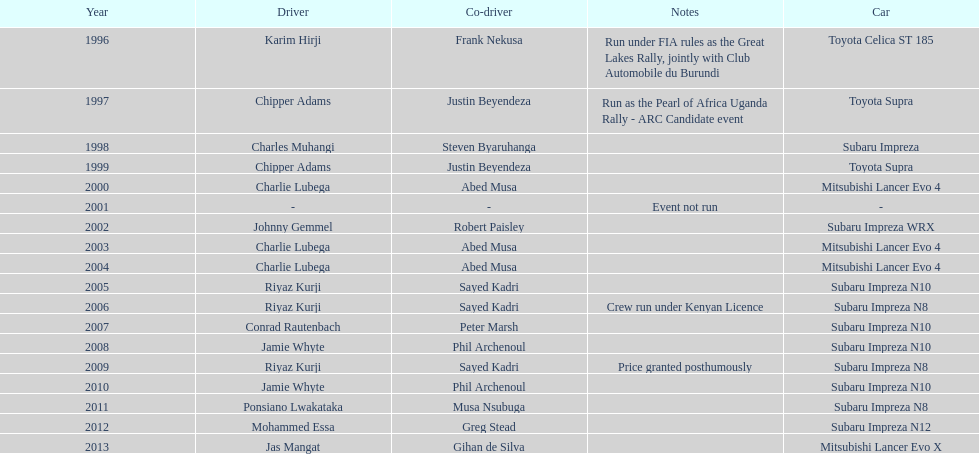How many drivers won at least twice? 4. 